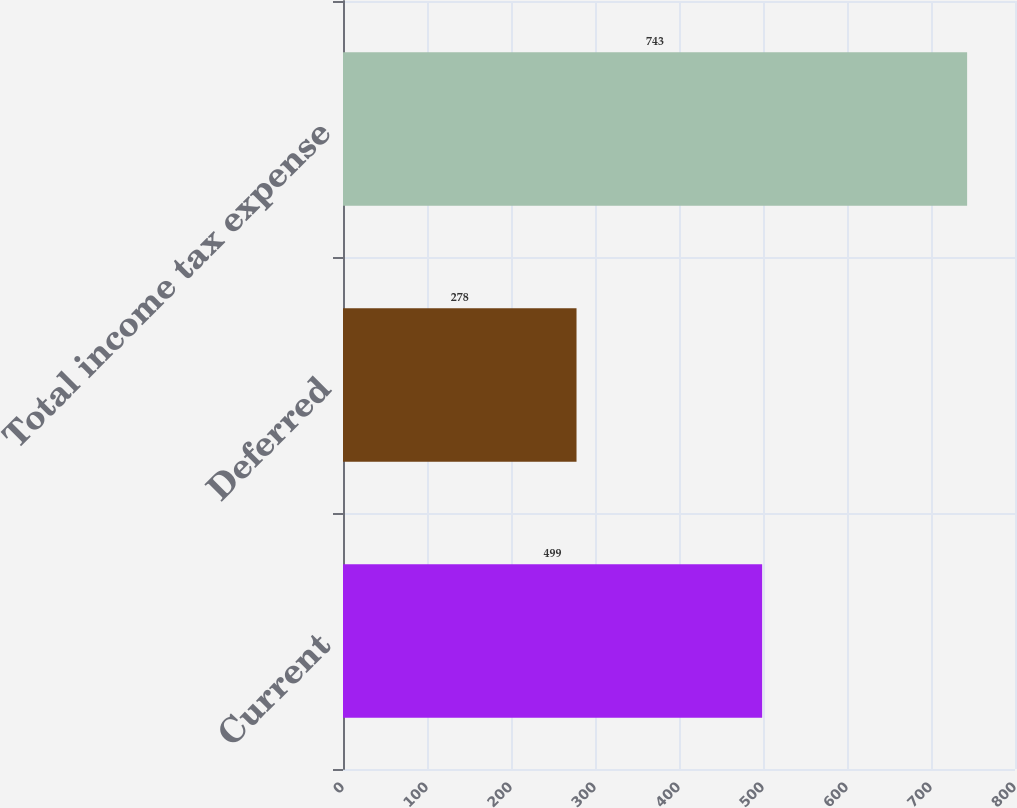Convert chart to OTSL. <chart><loc_0><loc_0><loc_500><loc_500><bar_chart><fcel>Current<fcel>Deferred<fcel>Total income tax expense<nl><fcel>499<fcel>278<fcel>743<nl></chart> 